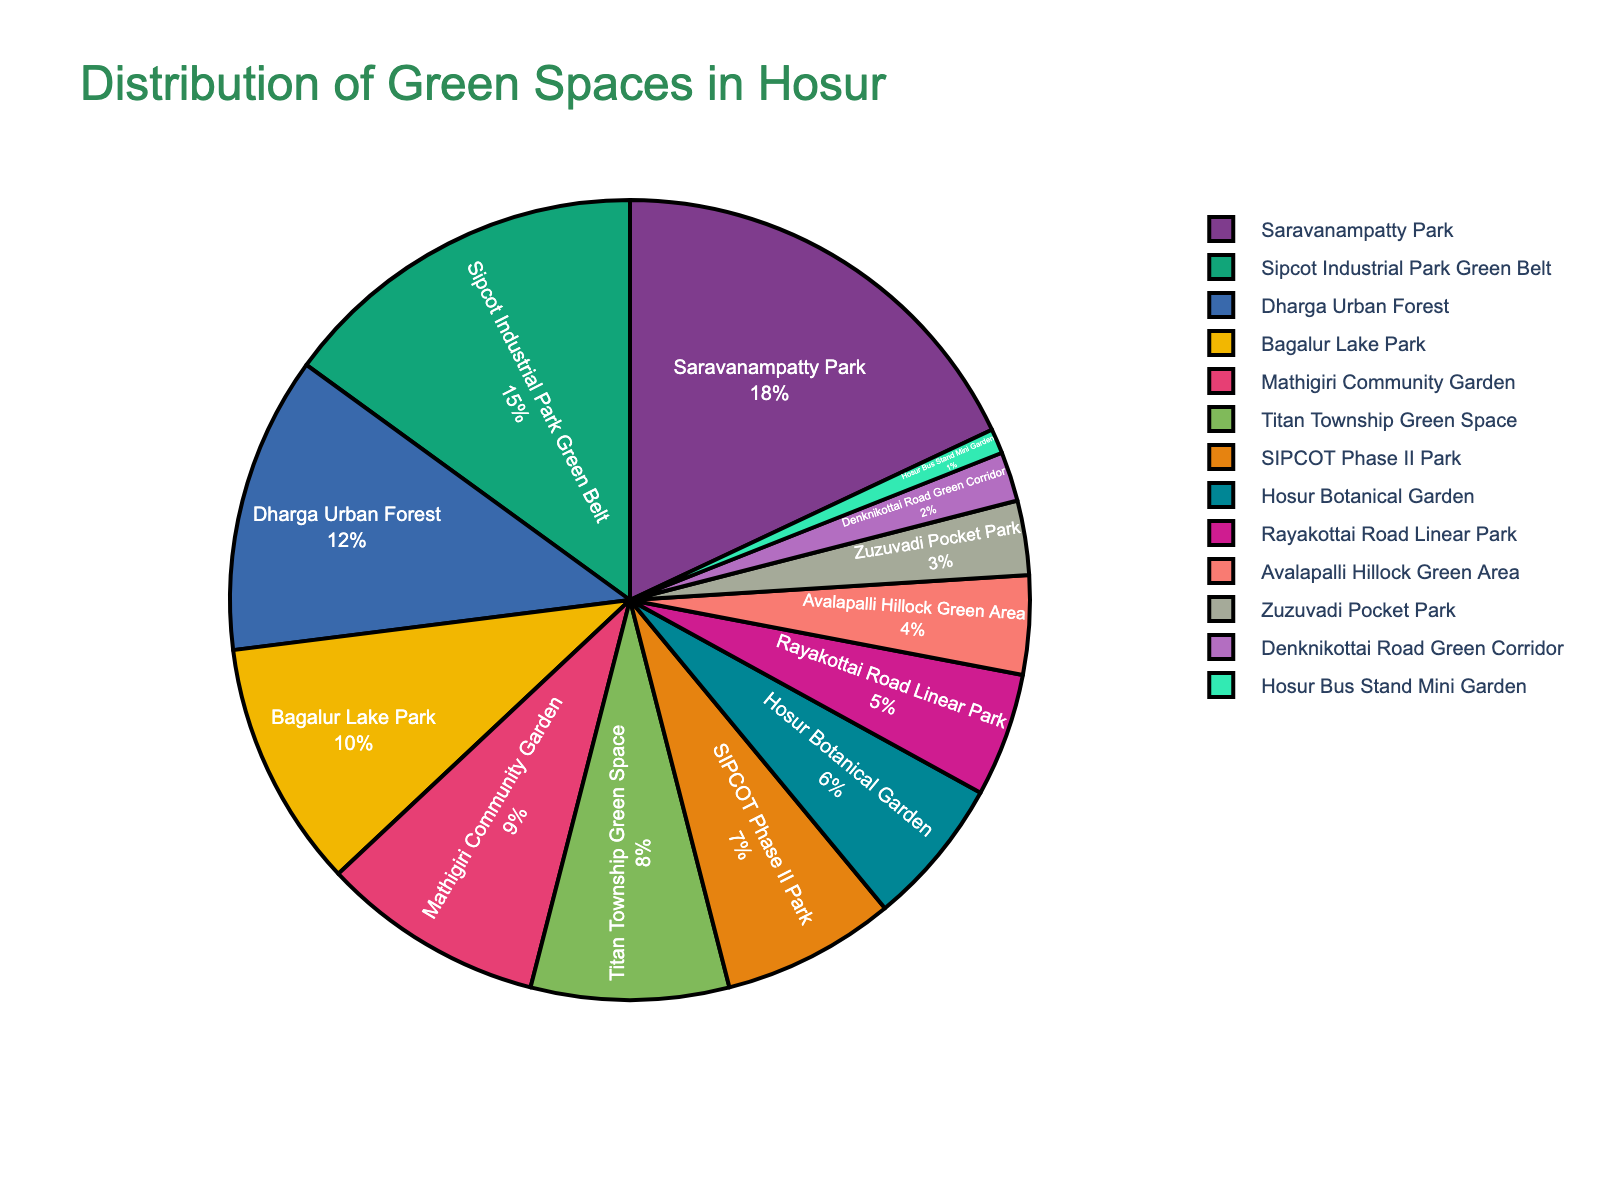What type of green space occupies the largest percentage in Hosur? The pie chart's title is "Distribution of Green Spaces in Hosur." By looking at the segments, Saravanampatty Park has the largest slice, indicating the highest percentage.
Answer: Saravanampatty Park Which green space has a larger percentage: Bagalur Lake Park or Mathigiri Community Garden? Compare the sizes of the slices for Bagalur Lake Park and Mathigiri Community Garden. Bagalur Lake Park is 10%, and Mathigiri Community Garden is 9%, so Bagalur Lake Park is larger.
Answer: Bagalur Lake Park What's the cumulative percentage of the two smallest green spaces? The two smallest green spaces are Hosur Bus Stand Mini Garden (1%) and Denknikottai Road Green Corridor (2%). Add their percentages: 1% + 2% = 3%.
Answer: 3% Is the combined percentage of urban forests higher than that of parks? First, identify the percentages for urban forests and parks. The only urban forest is Dharga Urban Forest (12%). Parks include Saravanampatty Park (18%), Sipcot Industrial Park Green Belt (15%), Bagalur Lake Park (10%), SIPCOT Phase II Park (7%), and Rayakottai Road Linear Park (5%). Sum the percentages for both categories. Urban forests: 12%. Parks: 18% + 15% + 10% + 7% + 5% = 55%. Since 55% (parks) > 12% (urban forests), the combined percentage of parks is higher.
Answer: No Which green space type is represented by the green color in the chart? Look at the pie chart and identify the segment colored green. Ensure you validate visually which section it represents. Let's assume Sipcot Industrial Park Green Belt is colored green for this example.
Answer: Sipcot Industrial Park Green Belt Calculate the average percentage of community gardens. Identify the community gardens and their percentages. Here, Mathigiri Community Garden is 9%. Since it's the only community garden listed, its percentage is the average: 9%/1 = 9%.
Answer: 9% Compare Titan Township Green Space and Hosur Botanical Garden. Which one has a higher percentage? Look at the pie chart slices for Titan Township Green Space (8%) and Hosur Botanical Garden (6%). Titan Township Green Space has a higher percentage.
Answer: Titan Township Green Space What is the difference in percentage between the largest and smallest green spaces? Identify the largest and smallest green spaces. The largest is Saravanampatty Park (18%), and the smallest is Hosur Bus Stand Mini Garden (1%). Subtract their percentages: 18% - 1% = 17%.
Answer: 17% Determine the sum of the percentages for SIPCOT green spaces. Add the percentages of SIPCOT green spaces: Sipcot Industrial Park Green Belt (15%) and SIPCOT Phase II Park (7%). Sum: 15% + 7% = 22%.
Answer: 22% Which has a higher percentage, Rayakottai Road Linear Park or Zuzuvadi Pocket Park? Compare the slices for Rayakottai Road Linear Park (5%) and Zuzuvadi Pocket Park (3%). Rayakottai Road Linear Park has a higher percentage.
Answer: Rayakottai Road Linear Park 